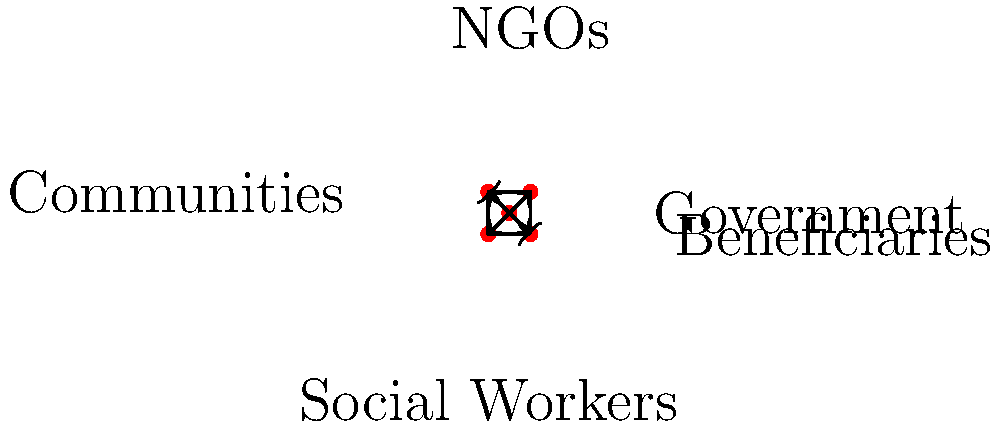In this network graph representing a social welfare system, which node acts as the primary intermediary between the government and the beneficiaries, often collecting stories and experiences that could inspire powerful verses? To answer this question, let's analyze the network graph step-by-step:

1. The graph shows five nodes: Government, NGOs, Communities, Social Workers, and Beneficiaries.

2. We need to identify which node serves as the main intermediary between the Government and Beneficiaries.

3. Looking at the arrows:
   - The Government has direct connections to NGOs, Communities, and Social Workers.
   - The Beneficiaries receive connections from NGOs, Communities, and Social Workers.
   - There's no direct connection between Government and Beneficiaries.

4. Among the three potential intermediaries (NGOs, Communities, and Social Workers), we need to consider which one is most likely to collect stories and experiences.

5. Social Workers, by the nature of their profession, work directly with individuals and families, gathering first-hand accounts of their struggles and triumphs.

6. In the context of inspiring powerful verses, the experiences and stories collected by Social Workers would provide rich, emotional material for a poet.

7. Therefore, the node representing Social Workers is the primary intermediary that fits the description in the question.
Answer: Social Workers 